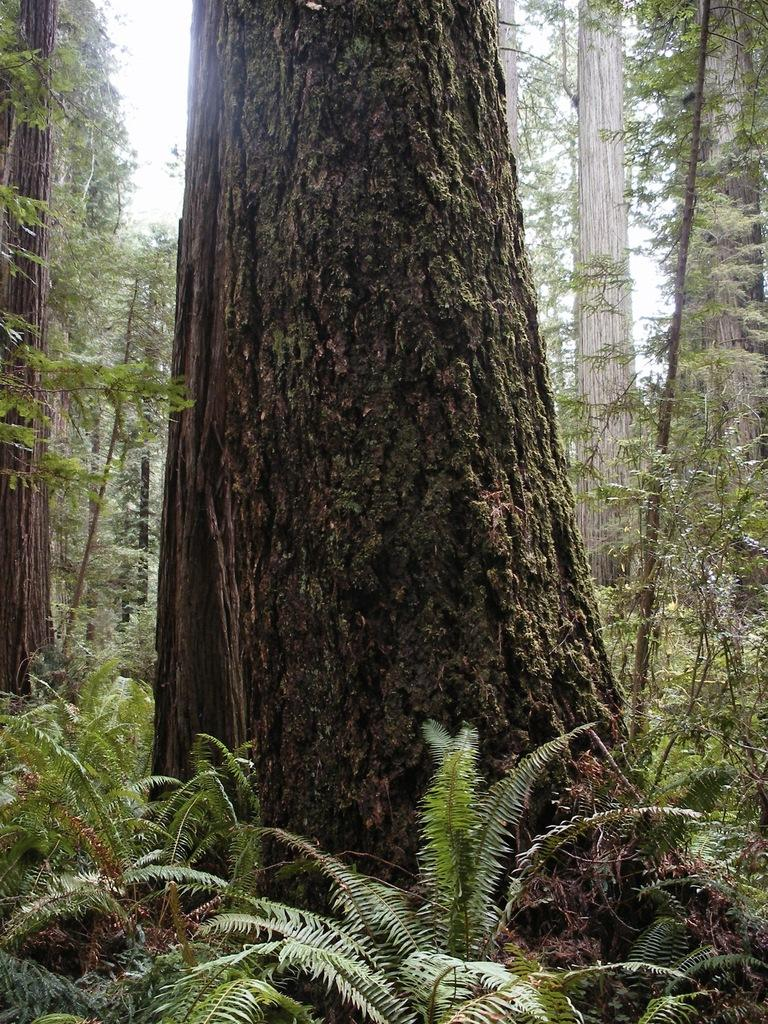What type of environment is shown in the image? The image depicts a forest area. What can be seen on the tree in the image? There is a tree branch in the image. What other vegetation is present near the tree branch? There are plants near the tree branch. What can be seen in the distance in the image? Trees and the sky are visible in the background of the image. What type of prose is being recited by the tree in the image? There is no indication in the image that the tree is reciting any prose. What type of fruit can be seen hanging from the tree branch in the image? There is no fruit visible on the tree branch in the image. 